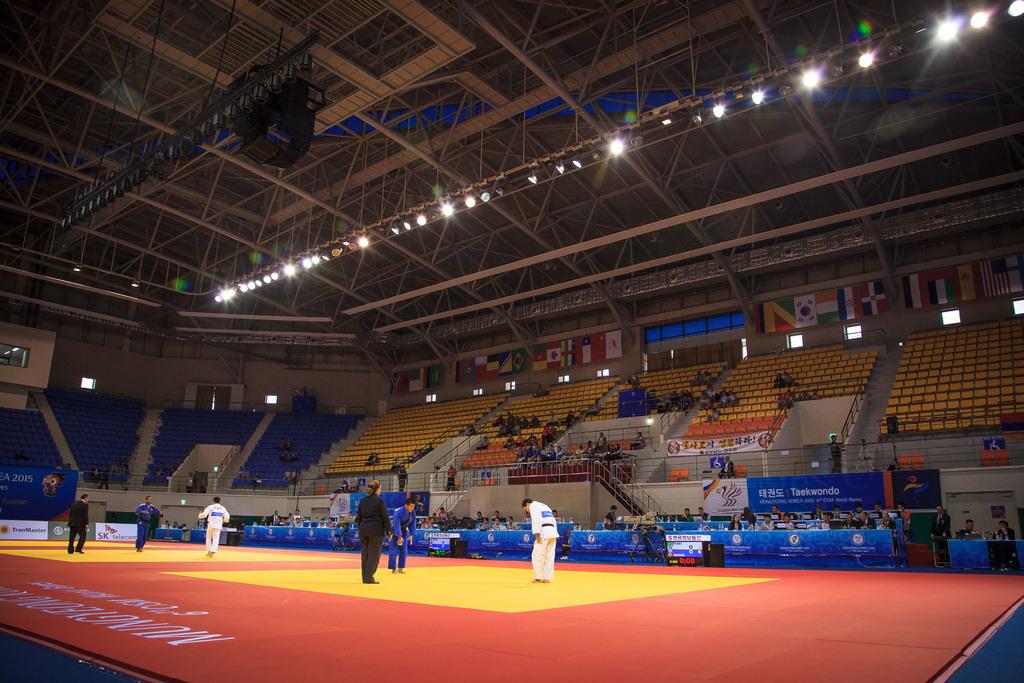What year is printed on the banner of the far left?
Your answer should be very brief. 2015. 